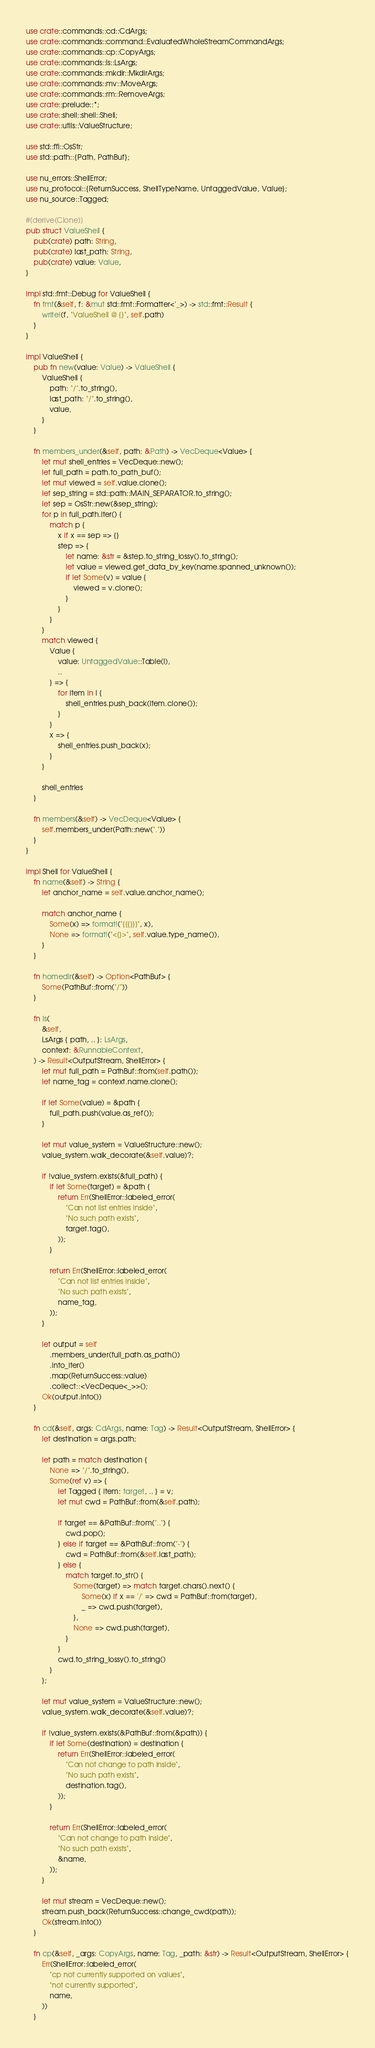Convert code to text. <code><loc_0><loc_0><loc_500><loc_500><_Rust_>use crate::commands::cd::CdArgs;
use crate::commands::command::EvaluatedWholeStreamCommandArgs;
use crate::commands::cp::CopyArgs;
use crate::commands::ls::LsArgs;
use crate::commands::mkdir::MkdirArgs;
use crate::commands::mv::MoveArgs;
use crate::commands::rm::RemoveArgs;
use crate::prelude::*;
use crate::shell::shell::Shell;
use crate::utils::ValueStructure;

use std::ffi::OsStr;
use std::path::{Path, PathBuf};

use nu_errors::ShellError;
use nu_protocol::{ReturnSuccess, ShellTypeName, UntaggedValue, Value};
use nu_source::Tagged;

#[derive(Clone)]
pub struct ValueShell {
    pub(crate) path: String,
    pub(crate) last_path: String,
    pub(crate) value: Value,
}

impl std::fmt::Debug for ValueShell {
    fn fmt(&self, f: &mut std::fmt::Formatter<'_>) -> std::fmt::Result {
        write!(f, "ValueShell @ {}", self.path)
    }
}

impl ValueShell {
    pub fn new(value: Value) -> ValueShell {
        ValueShell {
            path: "/".to_string(),
            last_path: "/".to_string(),
            value,
        }
    }

    fn members_under(&self, path: &Path) -> VecDeque<Value> {
        let mut shell_entries = VecDeque::new();
        let full_path = path.to_path_buf();
        let mut viewed = self.value.clone();
        let sep_string = std::path::MAIN_SEPARATOR.to_string();
        let sep = OsStr::new(&sep_string);
        for p in full_path.iter() {
            match p {
                x if x == sep => {}
                step => {
                    let name: &str = &step.to_string_lossy().to_string();
                    let value = viewed.get_data_by_key(name.spanned_unknown());
                    if let Some(v) = value {
                        viewed = v.clone();
                    }
                }
            }
        }
        match viewed {
            Value {
                value: UntaggedValue::Table(l),
                ..
            } => {
                for item in l {
                    shell_entries.push_back(item.clone());
                }
            }
            x => {
                shell_entries.push_back(x);
            }
        }

        shell_entries
    }

    fn members(&self) -> VecDeque<Value> {
        self.members_under(Path::new("."))
    }
}

impl Shell for ValueShell {
    fn name(&self) -> String {
        let anchor_name = self.value.anchor_name();

        match anchor_name {
            Some(x) => format!("{{{}}}", x),
            None => format!("<{}>", self.value.type_name()),
        }
    }

    fn homedir(&self) -> Option<PathBuf> {
        Some(PathBuf::from("/"))
    }

    fn ls(
        &self,
        LsArgs { path, .. }: LsArgs,
        context: &RunnableContext,
    ) -> Result<OutputStream, ShellError> {
        let mut full_path = PathBuf::from(self.path());
        let name_tag = context.name.clone();

        if let Some(value) = &path {
            full_path.push(value.as_ref());
        }

        let mut value_system = ValueStructure::new();
        value_system.walk_decorate(&self.value)?;

        if !value_system.exists(&full_path) {
            if let Some(target) = &path {
                return Err(ShellError::labeled_error(
                    "Can not list entries inside",
                    "No such path exists",
                    target.tag(),
                ));
            }

            return Err(ShellError::labeled_error(
                "Can not list entries inside",
                "No such path exists",
                name_tag,
            ));
        }

        let output = self
            .members_under(full_path.as_path())
            .into_iter()
            .map(ReturnSuccess::value)
            .collect::<VecDeque<_>>();
        Ok(output.into())
    }

    fn cd(&self, args: CdArgs, name: Tag) -> Result<OutputStream, ShellError> {
        let destination = args.path;

        let path = match destination {
            None => "/".to_string(),
            Some(ref v) => {
                let Tagged { item: target, .. } = v;
                let mut cwd = PathBuf::from(&self.path);

                if target == &PathBuf::from("..") {
                    cwd.pop();
                } else if target == &PathBuf::from("-") {
                    cwd = PathBuf::from(&self.last_path);
                } else {
                    match target.to_str() {
                        Some(target) => match target.chars().next() {
                            Some(x) if x == '/' => cwd = PathBuf::from(target),
                            _ => cwd.push(target),
                        },
                        None => cwd.push(target),
                    }
                }
                cwd.to_string_lossy().to_string()
            }
        };

        let mut value_system = ValueStructure::new();
        value_system.walk_decorate(&self.value)?;

        if !value_system.exists(&PathBuf::from(&path)) {
            if let Some(destination) = destination {
                return Err(ShellError::labeled_error(
                    "Can not change to path inside",
                    "No such path exists",
                    destination.tag(),
                ));
            }

            return Err(ShellError::labeled_error(
                "Can not change to path inside",
                "No such path exists",
                &name,
            ));
        }

        let mut stream = VecDeque::new();
        stream.push_back(ReturnSuccess::change_cwd(path));
        Ok(stream.into())
    }

    fn cp(&self, _args: CopyArgs, name: Tag, _path: &str) -> Result<OutputStream, ShellError> {
        Err(ShellError::labeled_error(
            "cp not currently supported on values",
            "not currently supported",
            name,
        ))
    }
</code> 